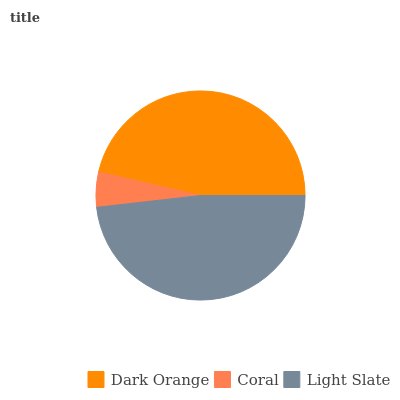Is Coral the minimum?
Answer yes or no. Yes. Is Light Slate the maximum?
Answer yes or no. Yes. Is Light Slate the minimum?
Answer yes or no. No. Is Coral the maximum?
Answer yes or no. No. Is Light Slate greater than Coral?
Answer yes or no. Yes. Is Coral less than Light Slate?
Answer yes or no. Yes. Is Coral greater than Light Slate?
Answer yes or no. No. Is Light Slate less than Coral?
Answer yes or no. No. Is Dark Orange the high median?
Answer yes or no. Yes. Is Dark Orange the low median?
Answer yes or no. Yes. Is Coral the high median?
Answer yes or no. No. Is Coral the low median?
Answer yes or no. No. 